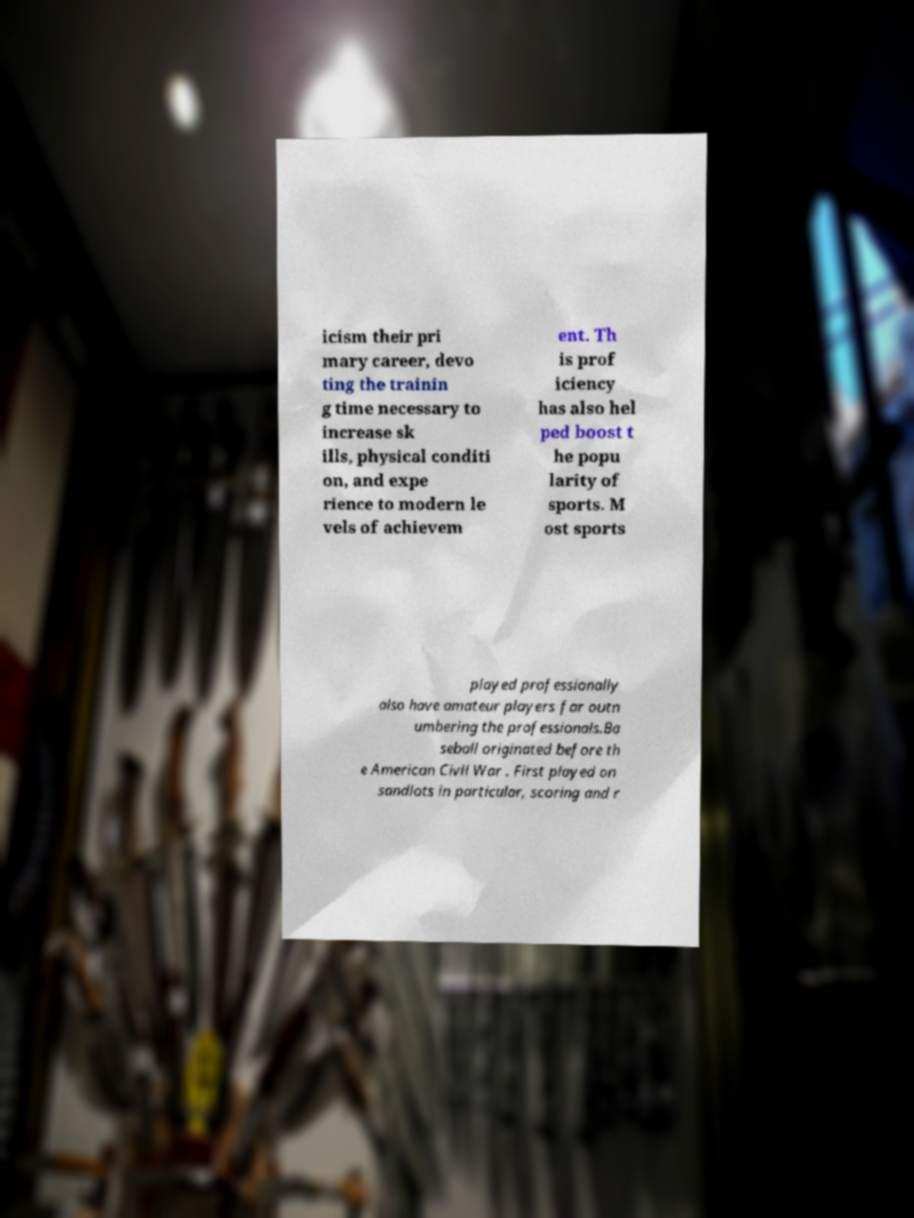For documentation purposes, I need the text within this image transcribed. Could you provide that? icism their pri mary career, devo ting the trainin g time necessary to increase sk ills, physical conditi on, and expe rience to modern le vels of achievem ent. Th is prof iciency has also hel ped boost t he popu larity of sports. M ost sports played professionally also have amateur players far outn umbering the professionals.Ba seball originated before th e American Civil War . First played on sandlots in particular, scoring and r 